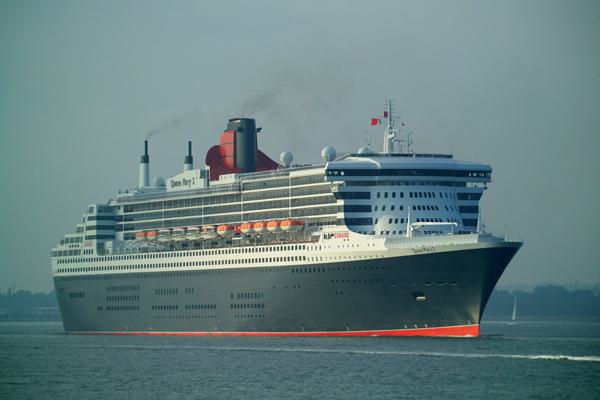What type of ship is in the image, and what can you tell me about it? This is a cruise ship, recognizable by its large-scale structure with multiple decks, a plethora of windows, and distinctive red-and-black funnel. Cruise ships like this are designed to offer guests a luxurious experience while traveling to various destinations across oceans and seas.  Given the design of the ship, how old do you think it is? The ship features a classic design with its red funnel and sleek hull, which might suggest it is a modern vessel designed with a traditional aesthetic. Without specific information, it's challenging to determine the exact age, but it could have been built anytime in the past few decades and maintained in good condition. 